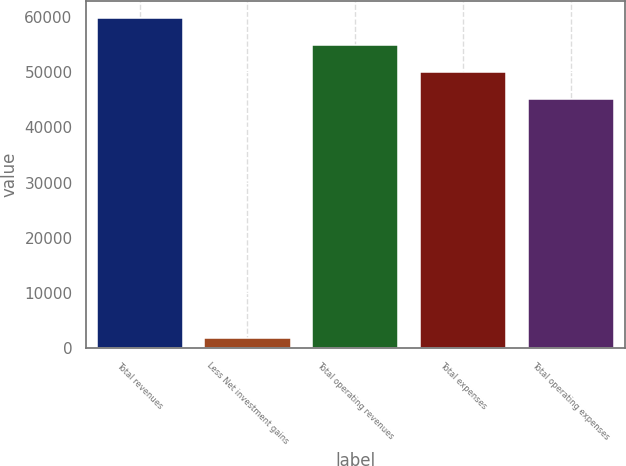Convert chart. <chart><loc_0><loc_0><loc_500><loc_500><bar_chart><fcel>Total revenues<fcel>Less Net investment gains<fcel>Total operating revenues<fcel>Total expenses<fcel>Total operating expenses<nl><fcel>59903.6<fcel>1812<fcel>54986.4<fcel>50069.2<fcel>45152<nl></chart> 